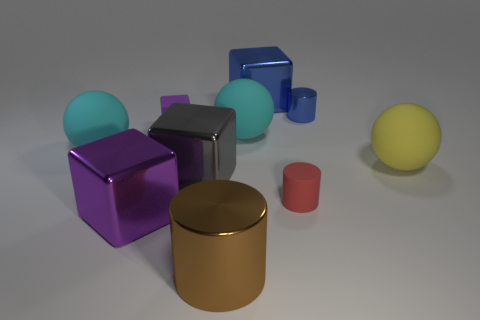There is a shiny thing that is the same color as the matte block; what size is it?
Offer a terse response. Large. Is there another tiny block that has the same material as the gray block?
Your response must be concise. No. Are there more cylinders than rubber cylinders?
Provide a short and direct response. Yes. Is the material of the big cylinder the same as the big blue object?
Ensure brevity in your answer.  Yes. How many rubber objects are either big gray cubes or brown cylinders?
Keep it short and to the point. 0. The cylinder that is the same size as the gray thing is what color?
Ensure brevity in your answer.  Brown. How many other blue things have the same shape as the tiny blue metallic object?
Keep it short and to the point. 0. How many cylinders are either tiny brown rubber things or brown objects?
Your answer should be compact. 1. Does the cyan object on the left side of the purple rubber object have the same shape as the purple object to the left of the small purple cube?
Make the answer very short. No. What is the material of the large blue object?
Keep it short and to the point. Metal. 